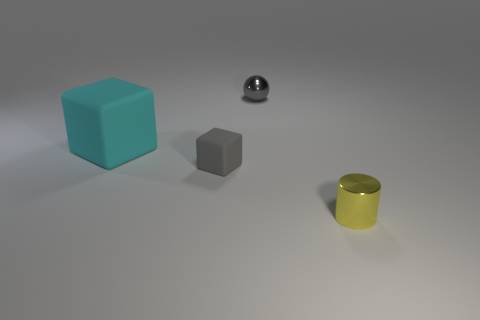What is the size of the yellow cylinder?
Provide a short and direct response. Small. There is a tiny cube that is the same color as the small ball; what is it made of?
Give a very brief answer. Rubber. How many rubber cubes have the same color as the small cylinder?
Offer a terse response. 0. Is the size of the metal cylinder the same as the gray rubber thing?
Your response must be concise. Yes. What is the size of the object on the right side of the small metallic object behind the yellow metallic cylinder?
Provide a short and direct response. Small. There is a tiny matte object; does it have the same color as the tiny object that is to the right of the gray metallic sphere?
Give a very brief answer. No. Is there another gray metal sphere of the same size as the gray metallic sphere?
Provide a succinct answer. No. What size is the matte cube behind the tiny matte block?
Offer a terse response. Large. Are there any large cyan matte cubes that are behind the small shiny object in front of the sphere?
Offer a very short reply. Yes. How many other objects are there of the same shape as the small yellow metal thing?
Provide a succinct answer. 0. 